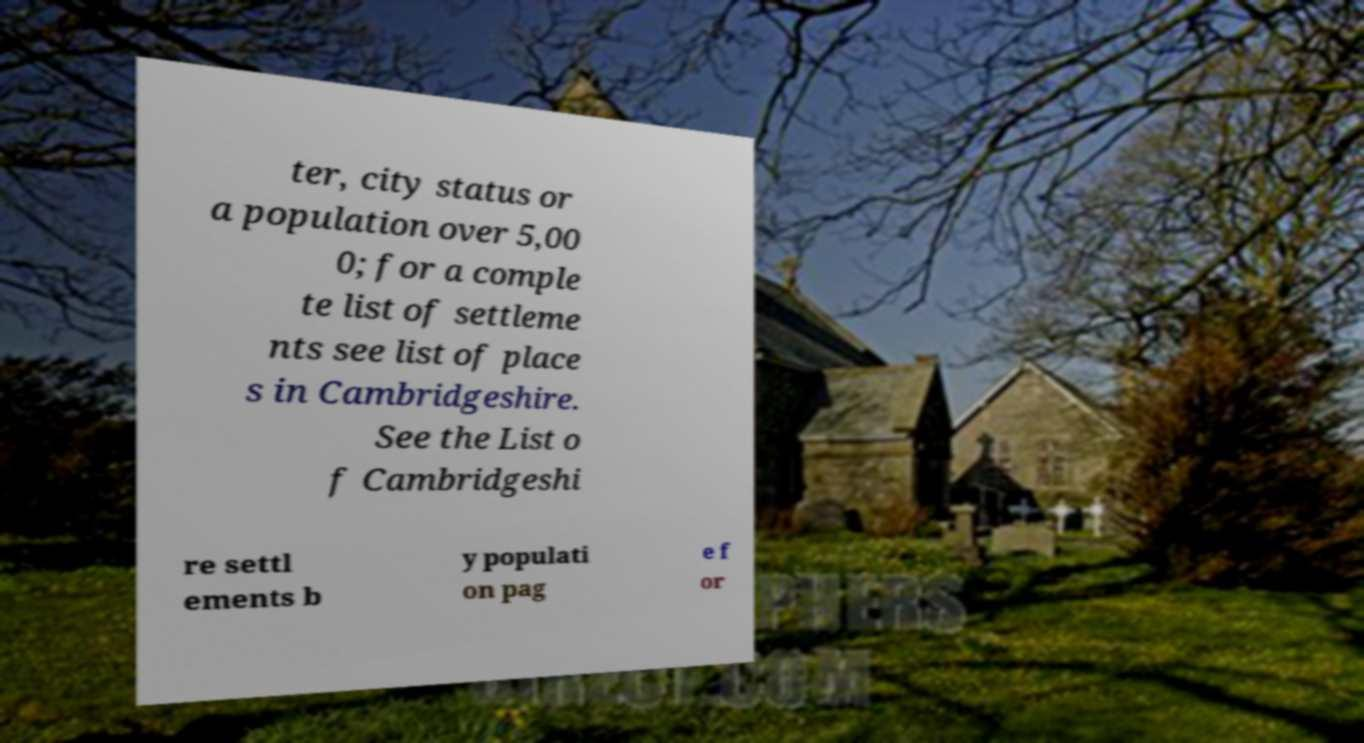Could you assist in decoding the text presented in this image and type it out clearly? ter, city status or a population over 5,00 0; for a comple te list of settleme nts see list of place s in Cambridgeshire. See the List o f Cambridgeshi re settl ements b y populati on pag e f or 